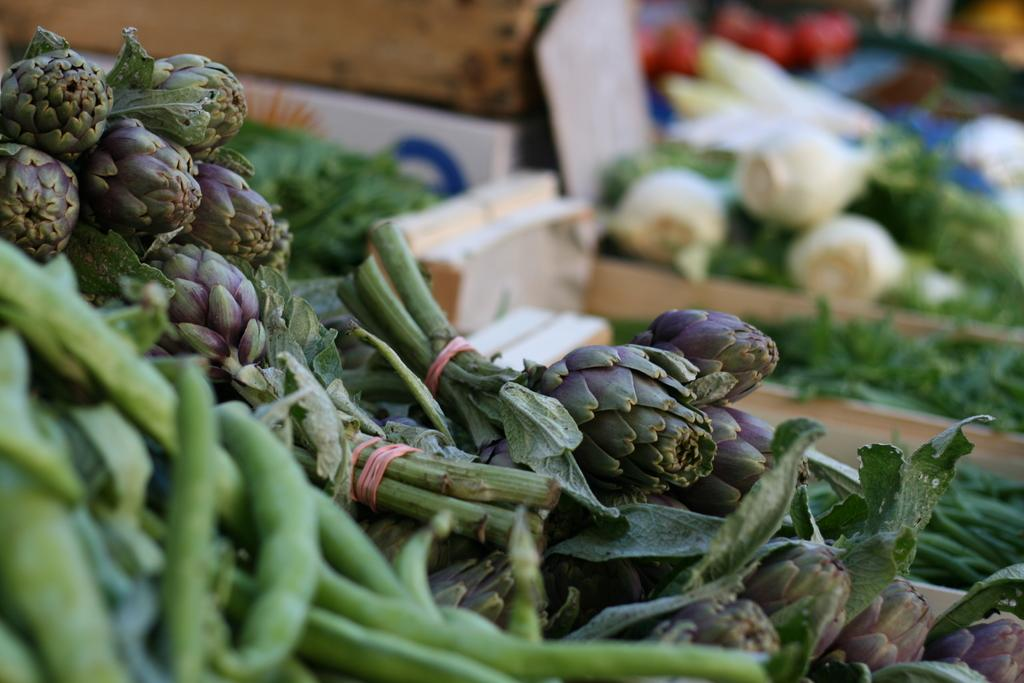What type of vegetables are in the foreground of the image? There are leafy vegetables in the foreground of the image. What other types of vegetables can be seen in the image? There are other vegetables in the background of the image. What type of list can be seen in the image? There is no list present in the image; it features leafy vegetables in the foreground and other vegetables in the background. 